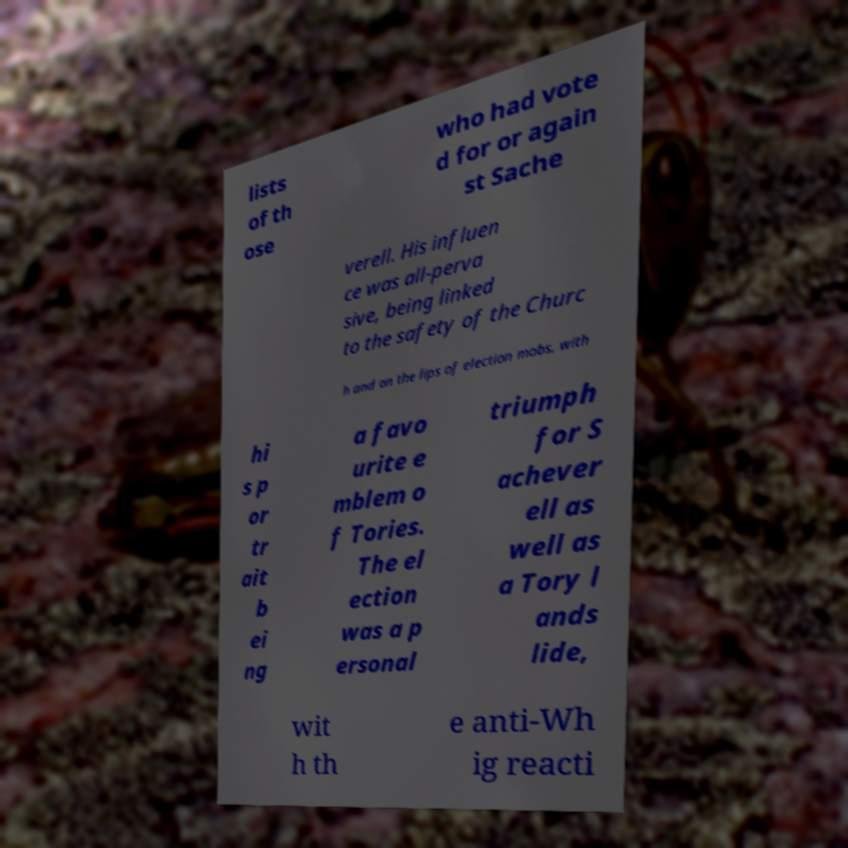I need the written content from this picture converted into text. Can you do that? lists of th ose who had vote d for or again st Sache verell. His influen ce was all-perva sive, being linked to the safety of the Churc h and on the lips of election mobs, with hi s p or tr ait b ei ng a favo urite e mblem o f Tories. The el ection was a p ersonal triumph for S achever ell as well as a Tory l ands lide, wit h th e anti-Wh ig reacti 